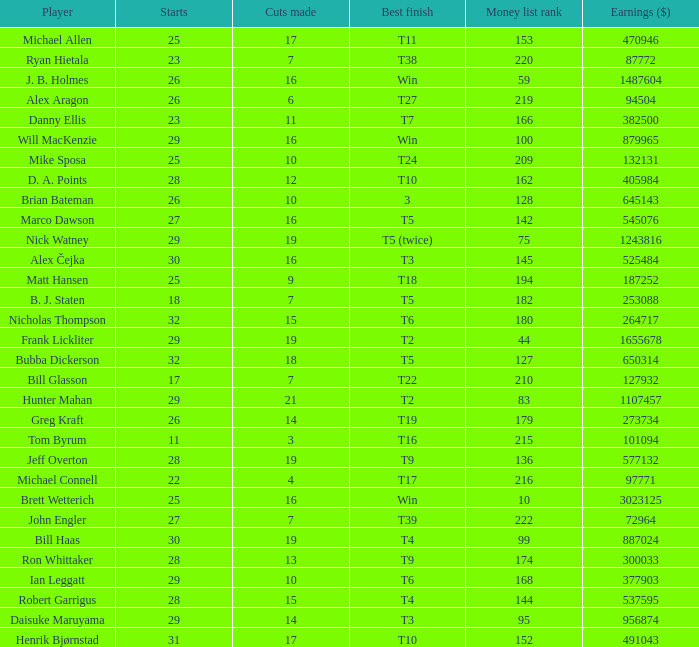What is the maximum money list rank for Matt Hansen? 194.0. 